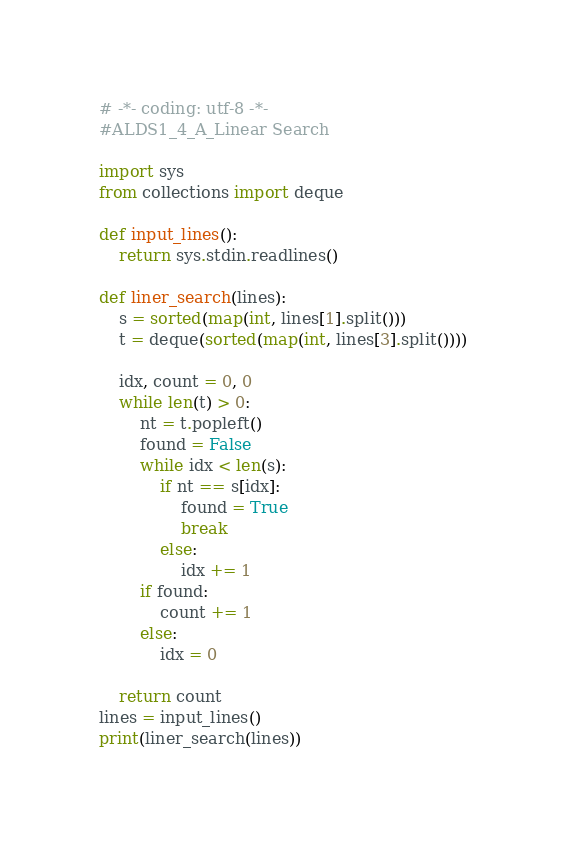<code> <loc_0><loc_0><loc_500><loc_500><_Python_># -*- coding: utf-8 -*-
#ALDS1_4_A_Linear Search

import sys
from collections import deque

def input_lines():
    return sys.stdin.readlines()

def liner_search(lines):
    s = sorted(map(int, lines[1].split()))
    t = deque(sorted(map(int, lines[3].split())))
    
    idx, count = 0, 0
    while len(t) > 0:
        nt = t.popleft()
        found = False
        while idx < len(s):
            if nt == s[idx]:
                found = True
                break
            else:
                idx += 1
        if found:
            count += 1
        else:
            idx = 0
        
    return count
lines = input_lines()
print(liner_search(lines))
</code> 